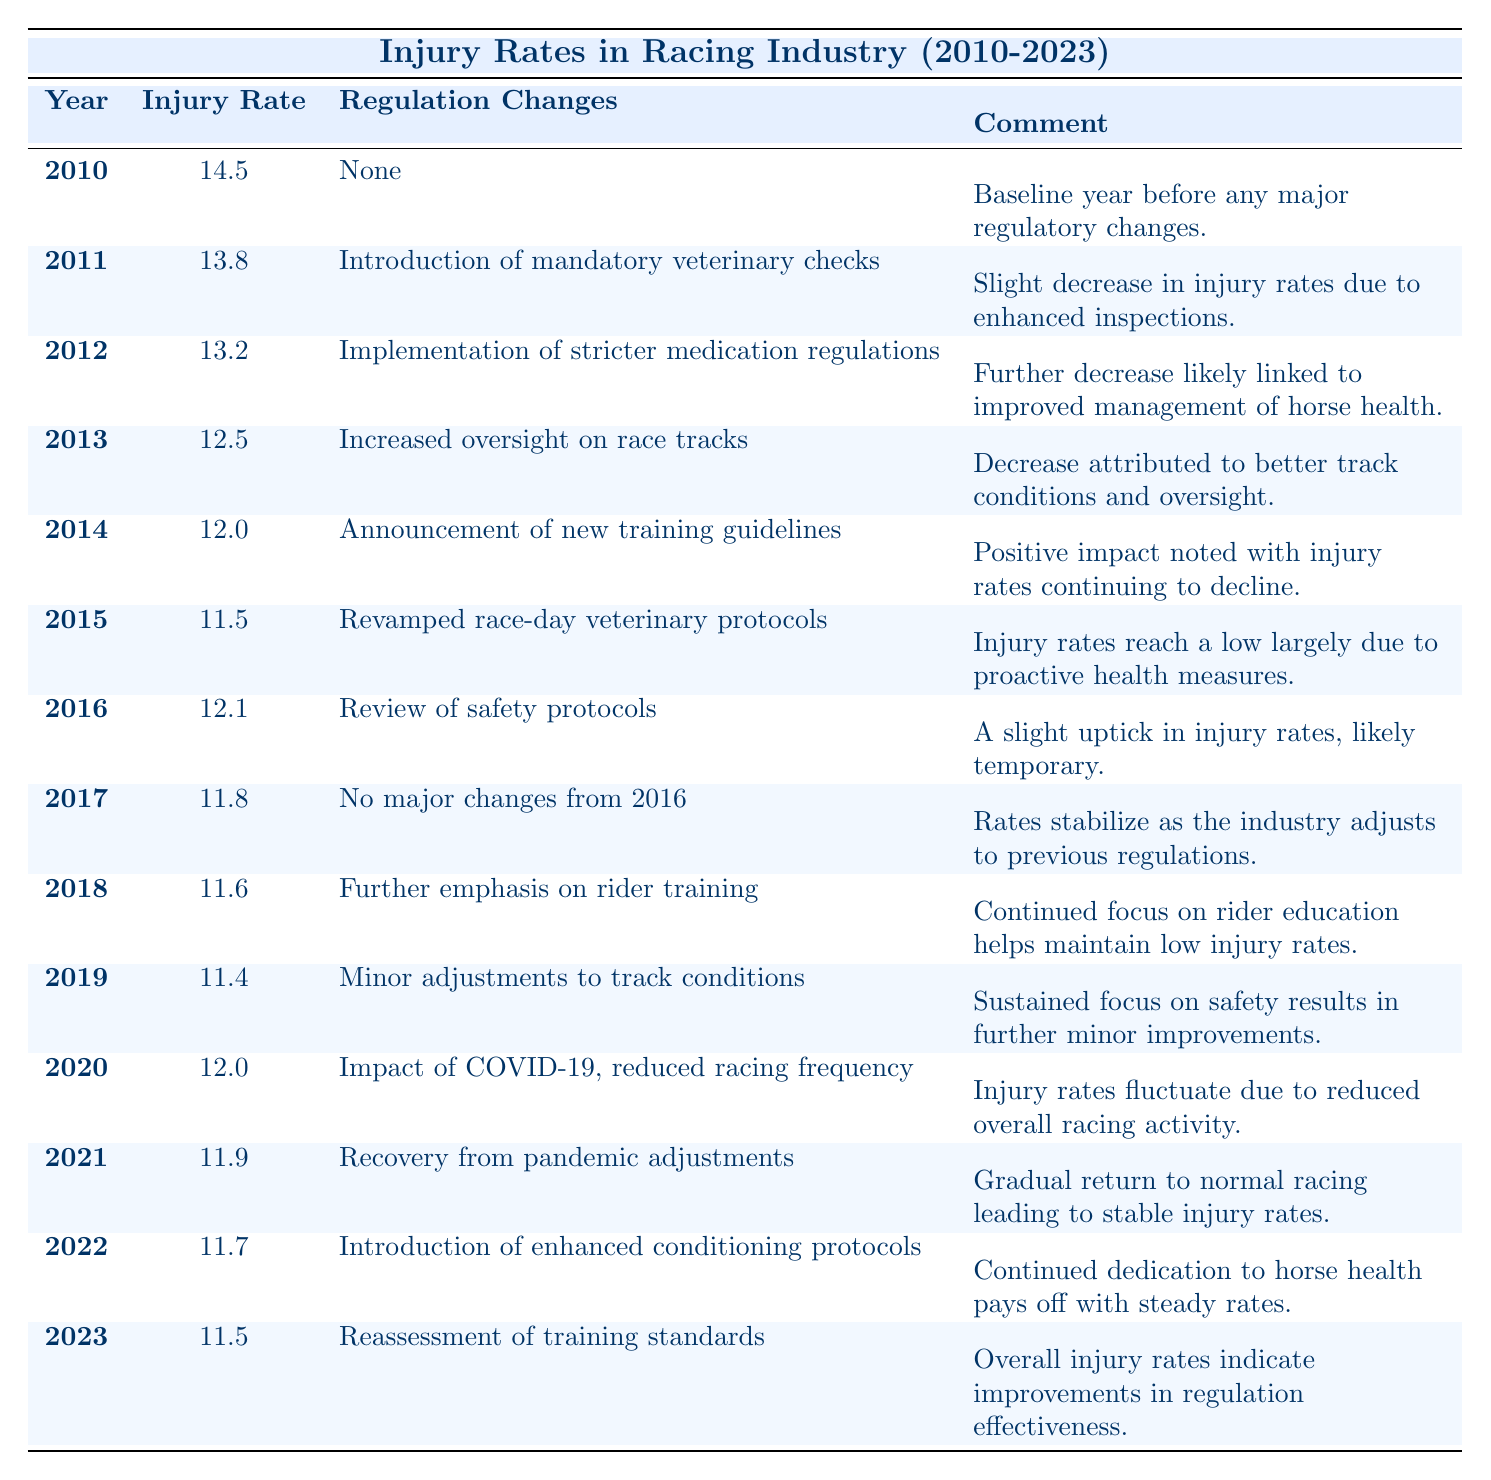What was the injury rate in 2010? The table shows the injury rate for the year 2010 as 14.5 injuries per 1000 races.
Answer: 14.5 What regulation change was introduced in 2011? The table indicates that in 2011, the introduction of mandatory veterinary checks was the regulation change.
Answer: Introduction of mandatory veterinary checks What was the lowest injury rate recorded? The lowest injury rate recorded in the table is 11.4 injuries per 1000 races in 2019.
Answer: 11.4 Which year saw an increase in injury rates compared to the previous year? In 2016, the injury rate increased to 12.1 from 11.5 in 2015, indicating an uptick.
Answer: 2016 Was there a steady decrease in injury rates between 2010 and 2015? Yes, the injury rates consistently decreased from 14.5 in 2010 to 11.5 in 2015, showing a steady decline.
Answer: Yes What is the average injury rate from 2010 to 2023? To find the average, we sum the injury rates from each year (14.5 + 13.8 + 13.2 + 12.5 + 12.0 + 11.5 + 12.1 + 11.8 + 11.6 + 11.4 + 12.0 + 11.9 + 11.7 + 11.5) = 168.0, and since there are 14 years, we calculate 168.0 / 14 = 12.0.
Answer: 12.0 What was the primary reason for the decrease in injury rates from 2010 to 2015? The injury rates decreased due to the implementation of various regulation changes such as improved inspections, stricter medication regulations, and proactive health measures.
Answer: Various regulation changes In which year was the assessment of training standards made? According to the table, the reassessment of training standards occurred in 2023.
Answer: 2023 How did the injury rate change from 2019 to 2021? The injury rate decreased from 11.4 in 2019 to 11.9 in 2021, indicating a slight fluctuation upwards.
Answer: Increased Was there any year where no major regulatory changes were reported? Yes, in 2017, it states there were no major changes from the previous year.
Answer: Yes What was the trend in injury rates from 2018 to 2023? From 2018, the injury rates fluctuated slightly but generally maintained stability with minor decrements, showing an overall improvement in regulation effectiveness by 2023.
Answer: Stabilized with minor decrements 